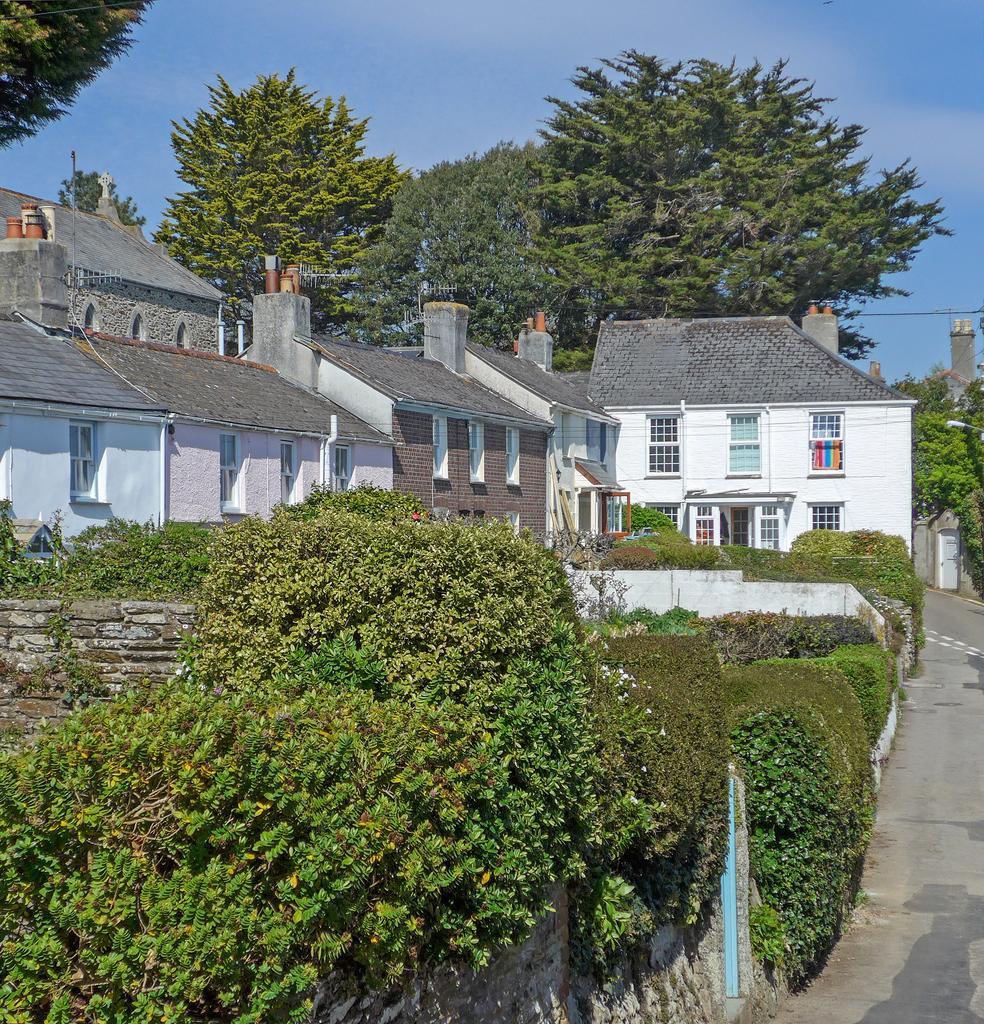Describe this image in one or two sentences. In this image, I can see the buildings with the windows and the bushes. These are the trees, which are behind the buildings. At the top of the image, I can see the sky. On the right side of the image, It looks like a pathway. 